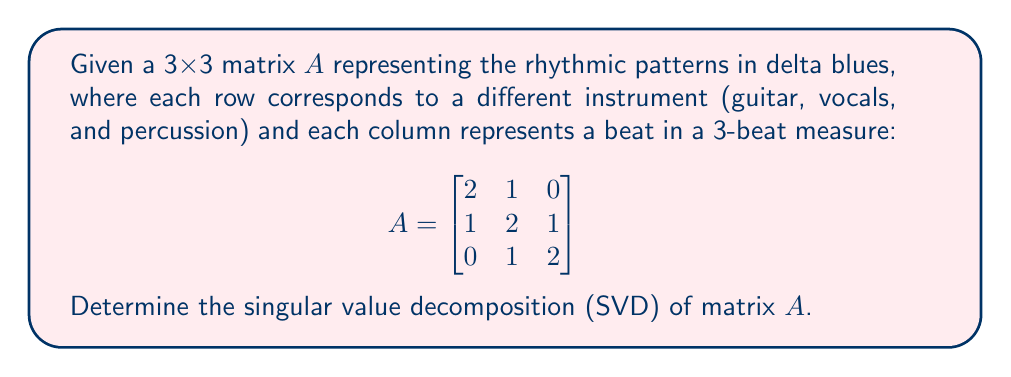Teach me how to tackle this problem. To find the singular value decomposition of matrix $A$, we need to express it as $A = U\Sigma V^T$, where $U$ and $V$ are orthogonal matrices and $\Sigma$ is a diagonal matrix containing the singular values.

Step 1: Calculate $A^TA$ and $AA^T$:

$$A^TA = \begin{bmatrix}
5 & 4 & 1 \\
4 & 6 & 4 \\
1 & 4 & 5
\end{bmatrix}$$

$$AA^T = \begin{bmatrix}
5 & 4 & 1 \\
4 & 6 & 4 \\
1 & 4 & 5
\end{bmatrix}$$

Step 2: Find the eigenvalues of $A^TA$ (or $AA^T$):
The characteristic equation is $\det(A^TA - \lambda I) = -\lambda^3 + 16\lambda^2 - 80\lambda + 125 = 0$
Solving this equation, we get eigenvalues: $\lambda_1 = 10$, $\lambda_2 = 5$, $\lambda_3 = 1$

Step 3: Calculate the singular values:
$\sigma_i = \sqrt{\lambda_i}$
$\sigma_1 = \sqrt{10}$, $\sigma_2 = \sqrt{5}$, $\sigma_3 = 1$

Step 4: Find the eigenvectors of $A^TA$ to get the columns of $V$:
For $\lambda_1 = 10$: $v_1 = \frac{1}{\sqrt{6}}[1, 2, 1]^T$
For $\lambda_2 = 5$: $v_2 = \frac{1}{\sqrt{2}}[1, 0, -1]^T$
For $\lambda_3 = 1$: $v_3 = \frac{1}{\sqrt{3}}[-1, 1, -1]^T$

Step 5: Calculate the columns of $U$ using $u_i = \frac{1}{\sigma_i}Av_i$:
$u_1 = \frac{1}{\sqrt{6}}[1, 2, 1]^T$
$u_2 = \frac{1}{\sqrt{2}}[1, 0, -1]^T$
$u_3 = \frac{1}{\sqrt{3}}[-1, 1, -1]^T$

Step 6: Construct the matrices $U$, $\Sigma$, and $V$:

$$U = \begin{bmatrix}
\frac{1}{\sqrt{6}} & \frac{1}{\sqrt{2}} & -\frac{1}{\sqrt{3}} \\
\frac{2}{\sqrt{6}} & 0 & \frac{1}{\sqrt{3}} \\
\frac{1}{\sqrt{6}} & -\frac{1}{\sqrt{2}} & -\frac{1}{\sqrt{3}}
\end{bmatrix}$$

$$\Sigma = \begin{bmatrix}
\sqrt{10} & 0 & 0 \\
0 & \sqrt{5} & 0 \\
0 & 0 & 1
\end{bmatrix}$$

$$V = \begin{bmatrix}
\frac{1}{\sqrt{6}} & \frac{1}{\sqrt{2}} & -\frac{1}{\sqrt{3}} \\
\frac{2}{\sqrt{6}} & 0 & \frac{1}{\sqrt{3}} \\
\frac{1}{\sqrt{6}} & -\frac{1}{\sqrt{2}} & -\frac{1}{\sqrt{3}}
\end{bmatrix}$$
Answer: $A = U\Sigma V^T$, where

$U = V = \begin{bmatrix}
\frac{1}{\sqrt{6}} & \frac{1}{\sqrt{2}} & -\frac{1}{\sqrt{3}} \\
\frac{2}{\sqrt{6}} & 0 & \frac{1}{\sqrt{3}} \\
\frac{1}{\sqrt{6}} & -\frac{1}{\sqrt{2}} & -\frac{1}{\sqrt{3}}
\end{bmatrix}$

$\Sigma = \begin{bmatrix}
\sqrt{10} & 0 & 0 \\
0 & \sqrt{5} & 0 \\
0 & 0 & 1
\end{bmatrix}$ 